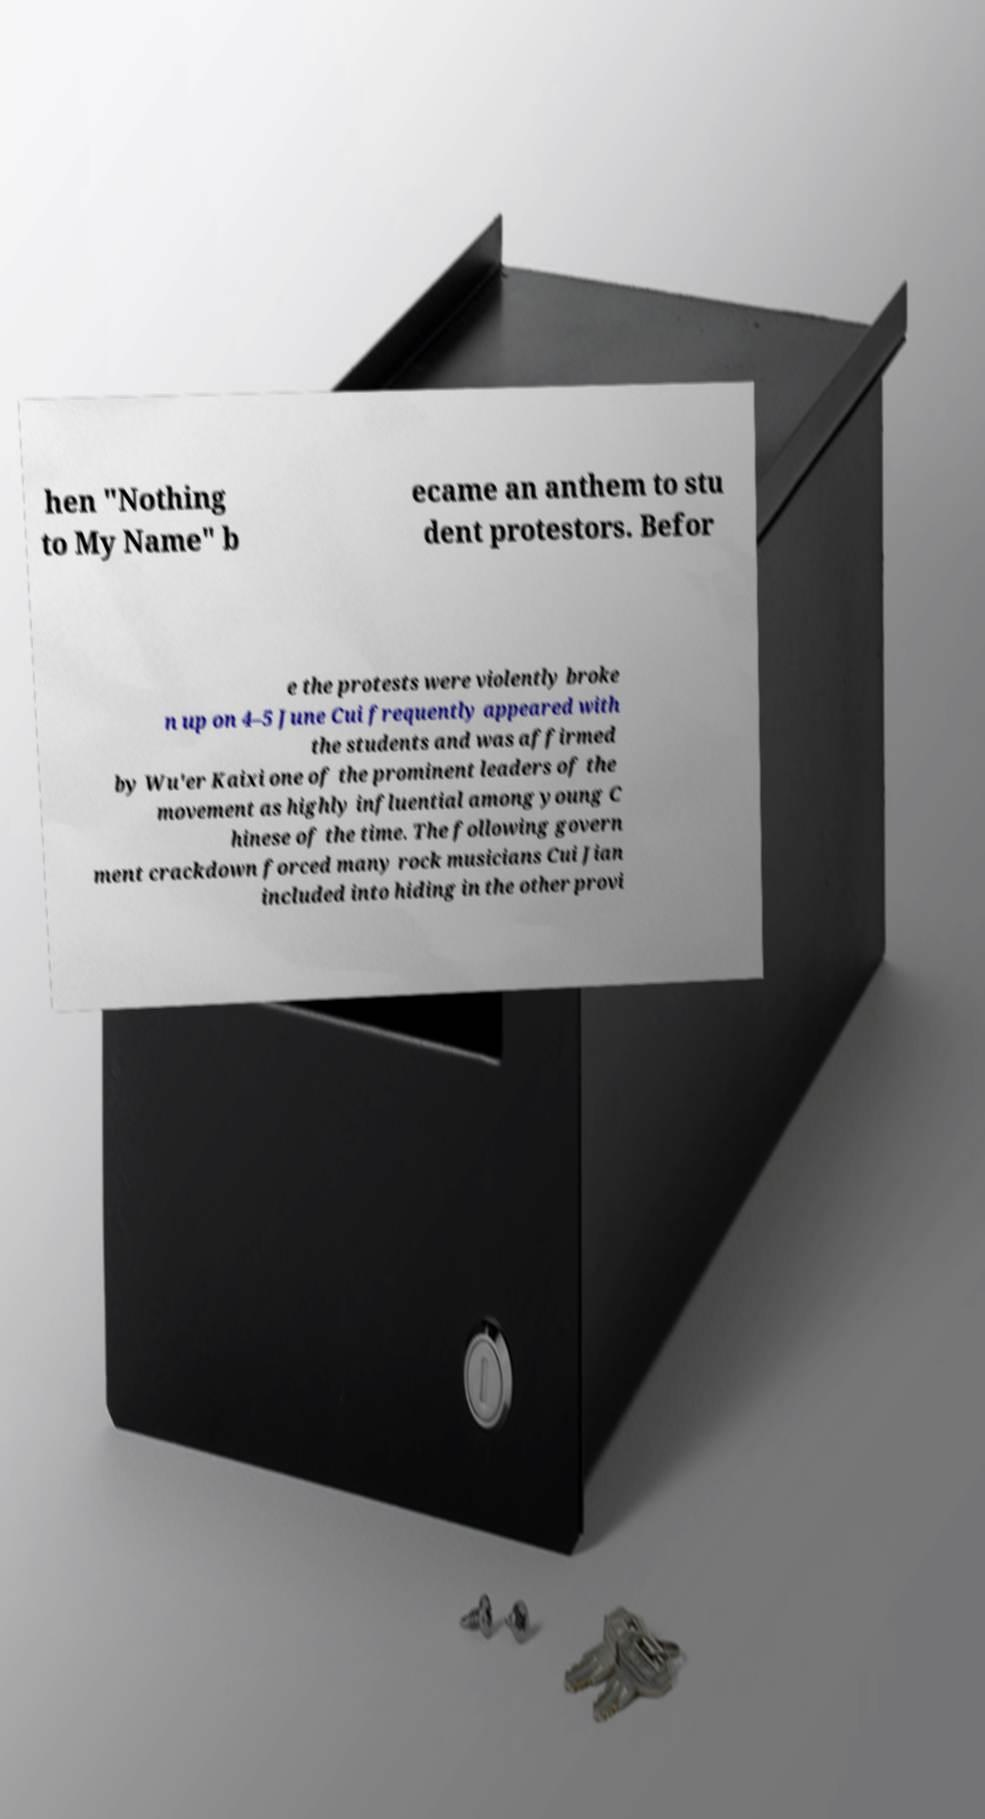There's text embedded in this image that I need extracted. Can you transcribe it verbatim? hen "Nothing to My Name" b ecame an anthem to stu dent protestors. Befor e the protests were violently broke n up on 4–5 June Cui frequently appeared with the students and was affirmed by Wu'er Kaixi one of the prominent leaders of the movement as highly influential among young C hinese of the time. The following govern ment crackdown forced many rock musicians Cui Jian included into hiding in the other provi 